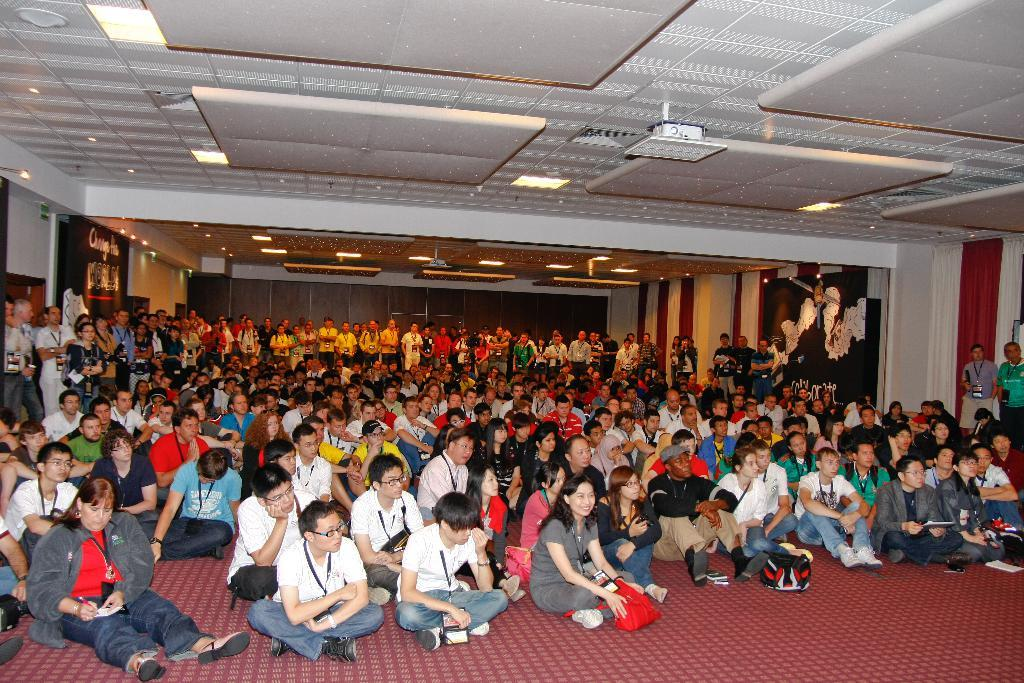What are the people in the image doing? Some people are sitting, and some are standing at the bottom of the image. What can be seen at the top of the image? There are lights visible at the top of the image. What is visible in the background of the image? There is a wall visible in the background of the image. What type of cake is being served at the event in the image? There is no cake present in the image, and no event is depicted. What kind of structure is the wall made of in the image? The provided facts do not mention the material of the wall, so it cannot be determined from the image. 